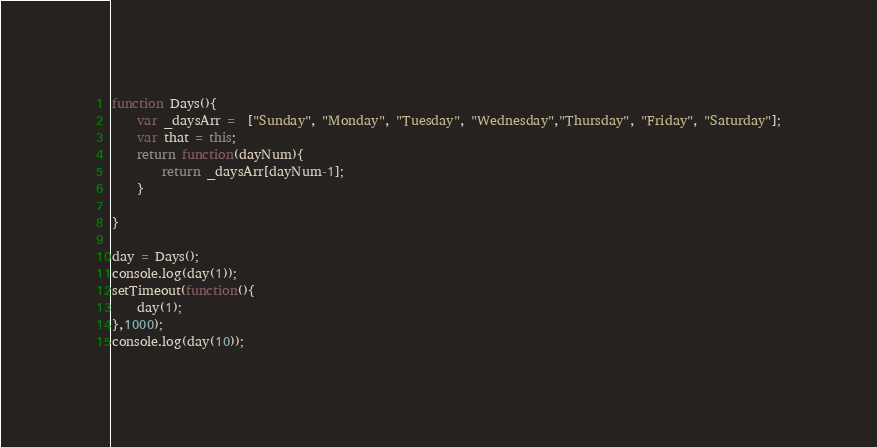<code> <loc_0><loc_0><loc_500><loc_500><_JavaScript_>function Days(){
	var _daysArr =  ["Sunday", "Monday", "Tuesday", "Wednesday","Thursday", "Friday", "Saturday"];
	var that = this;
	return function(dayNum){
		return _daysArr[dayNum-1];
	}
	
}

day = Days();
console.log(day(1));
setTimeout(function(){
	day(1);
},1000);
console.log(day(10));
</code> 